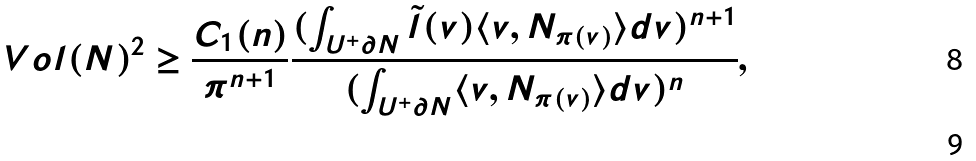Convert formula to latex. <formula><loc_0><loc_0><loc_500><loc_500>\ V o l ( N ) ^ { 2 } & \geq \frac { C _ { 1 } ( n ) } { \pi ^ { n + 1 } } \frac { ( \int _ { U ^ { + } \partial N } \tilde { l } ( v ) \langle v , N _ { \pi ( v ) } \rangle d v ) ^ { n + 1 } } { ( \int _ { U ^ { + } \partial N } \langle v , N _ { \pi ( v ) } \rangle d v ) ^ { n } } , \\</formula> 